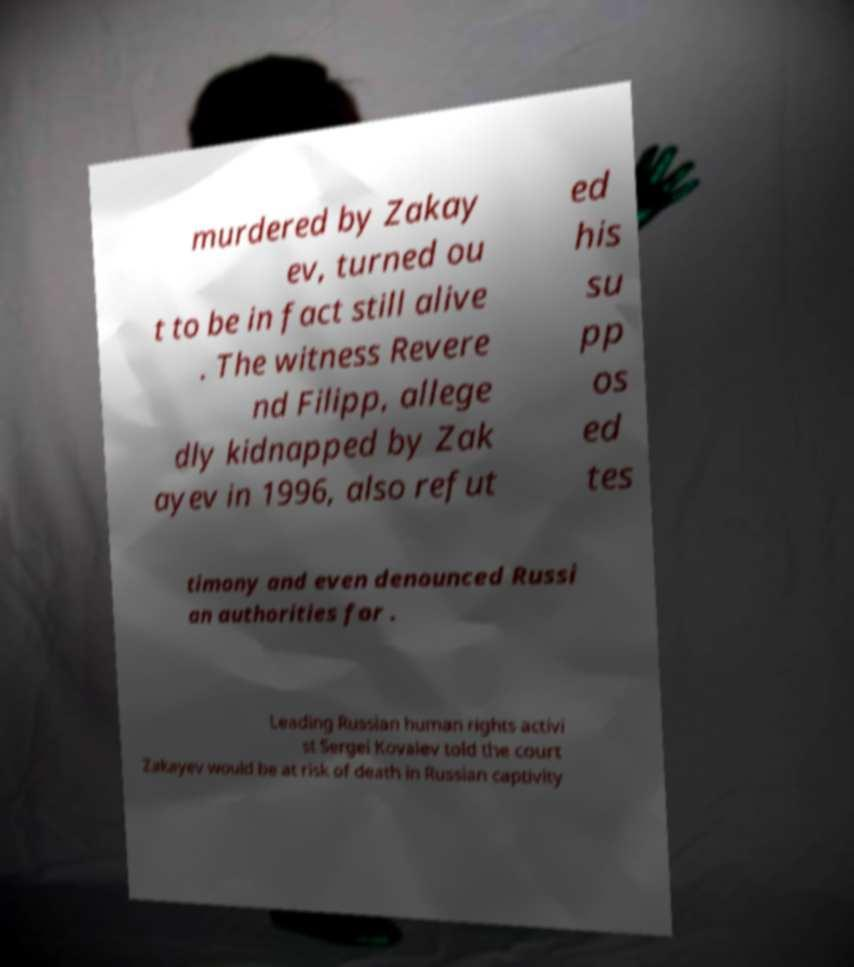For documentation purposes, I need the text within this image transcribed. Could you provide that? murdered by Zakay ev, turned ou t to be in fact still alive . The witness Revere nd Filipp, allege dly kidnapped by Zak ayev in 1996, also refut ed his su pp os ed tes timony and even denounced Russi an authorities for . Leading Russian human rights activi st Sergei Kovalev told the court Zakayev would be at risk of death in Russian captivity 